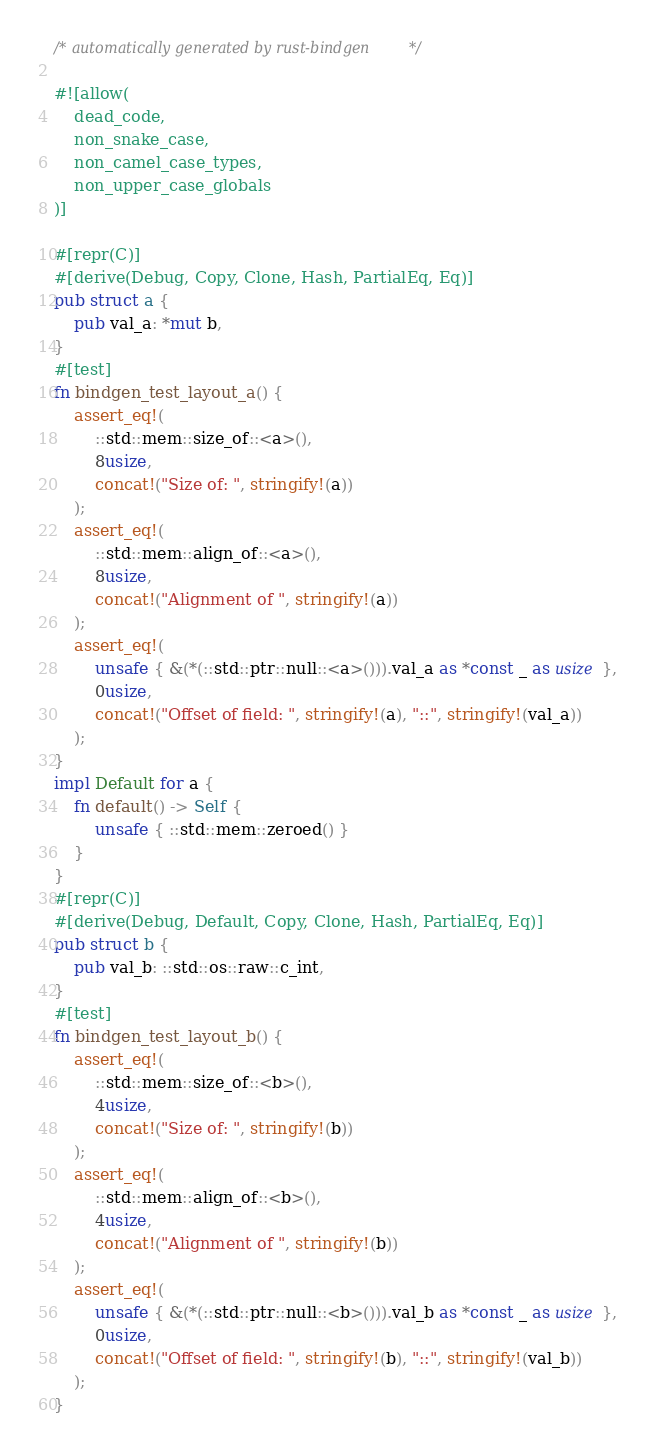Convert code to text. <code><loc_0><loc_0><loc_500><loc_500><_Rust_>/* automatically generated by rust-bindgen */

#![allow(
    dead_code,
    non_snake_case,
    non_camel_case_types,
    non_upper_case_globals
)]

#[repr(C)]
#[derive(Debug, Copy, Clone, Hash, PartialEq, Eq)]
pub struct a {
    pub val_a: *mut b,
}
#[test]
fn bindgen_test_layout_a() {
    assert_eq!(
        ::std::mem::size_of::<a>(),
        8usize,
        concat!("Size of: ", stringify!(a))
    );
    assert_eq!(
        ::std::mem::align_of::<a>(),
        8usize,
        concat!("Alignment of ", stringify!(a))
    );
    assert_eq!(
        unsafe { &(*(::std::ptr::null::<a>())).val_a as *const _ as usize },
        0usize,
        concat!("Offset of field: ", stringify!(a), "::", stringify!(val_a))
    );
}
impl Default for a {
    fn default() -> Self {
        unsafe { ::std::mem::zeroed() }
    }
}
#[repr(C)]
#[derive(Debug, Default, Copy, Clone, Hash, PartialEq, Eq)]
pub struct b {
    pub val_b: ::std::os::raw::c_int,
}
#[test]
fn bindgen_test_layout_b() {
    assert_eq!(
        ::std::mem::size_of::<b>(),
        4usize,
        concat!("Size of: ", stringify!(b))
    );
    assert_eq!(
        ::std::mem::align_of::<b>(),
        4usize,
        concat!("Alignment of ", stringify!(b))
    );
    assert_eq!(
        unsafe { &(*(::std::ptr::null::<b>())).val_b as *const _ as usize },
        0usize,
        concat!("Offset of field: ", stringify!(b), "::", stringify!(val_b))
    );
}
</code> 